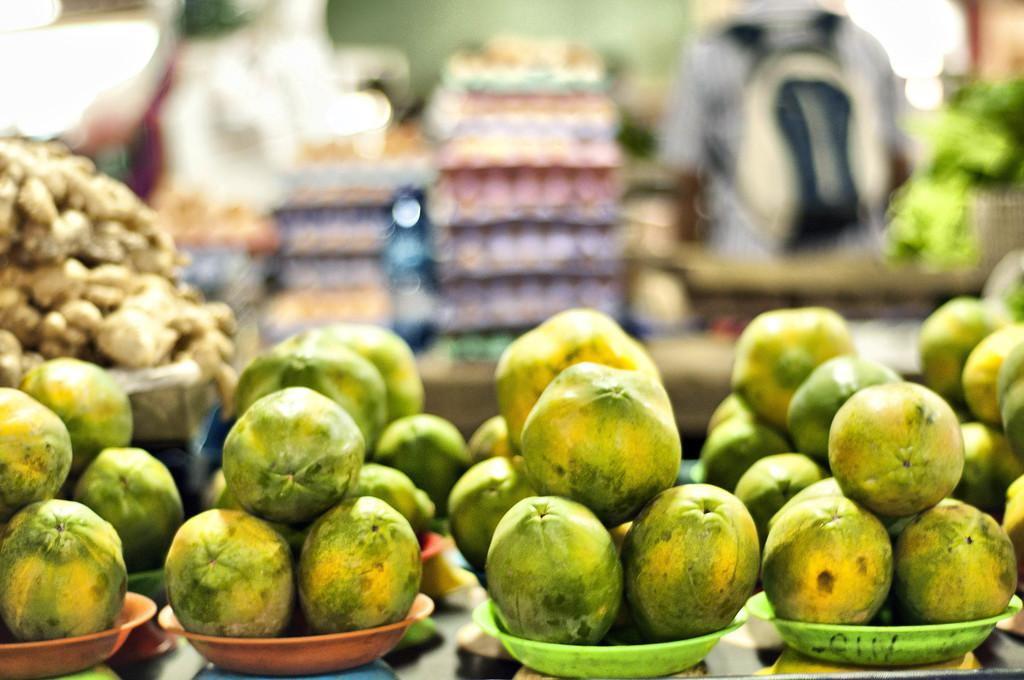What type of food can be seen in the bowls in the image? There are bowls of fruits in the image. Can you describe the background of the image? The background of the image is blurred. What is the person in the image wearing? There is a person wearing a bag in the image. What other unspecified objects can be seen in the image? There are some other unspecified objects in the image, but we cannot provide more details without additional information. What type of grass is growing in the image? There is no grass present in the image. What emotion is the person in the image experiencing? We cannot determine the emotion of the person in the image from the provided facts. 